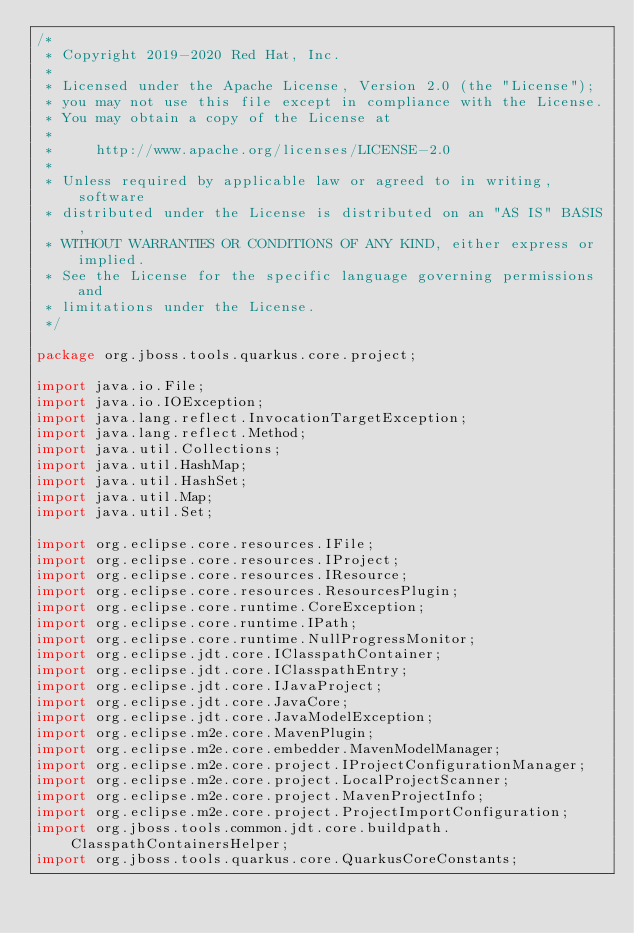<code> <loc_0><loc_0><loc_500><loc_500><_Java_>/*
 * Copyright 2019-2020 Red Hat, Inc.
 *
 * Licensed under the Apache License, Version 2.0 (the "License");
 * you may not use this file except in compliance with the License.
 * You may obtain a copy of the License at
 *
 *     http://www.apache.org/licenses/LICENSE-2.0
 *
 * Unless required by applicable law or agreed to in writing, software
 * distributed under the License is distributed on an "AS IS" BASIS,
 * WITHOUT WARRANTIES OR CONDITIONS OF ANY KIND, either express or implied.
 * See the License for the specific language governing permissions and
 * limitations under the License.
 */

package org.jboss.tools.quarkus.core.project;

import java.io.File;
import java.io.IOException;
import java.lang.reflect.InvocationTargetException;
import java.lang.reflect.Method;
import java.util.Collections;
import java.util.HashMap;
import java.util.HashSet;
import java.util.Map;
import java.util.Set;

import org.eclipse.core.resources.IFile;
import org.eclipse.core.resources.IProject;
import org.eclipse.core.resources.IResource;
import org.eclipse.core.resources.ResourcesPlugin;
import org.eclipse.core.runtime.CoreException;
import org.eclipse.core.runtime.IPath;
import org.eclipse.core.runtime.NullProgressMonitor;
import org.eclipse.jdt.core.IClasspathContainer;
import org.eclipse.jdt.core.IClasspathEntry;
import org.eclipse.jdt.core.IJavaProject;
import org.eclipse.jdt.core.JavaCore;
import org.eclipse.jdt.core.JavaModelException;
import org.eclipse.m2e.core.MavenPlugin;
import org.eclipse.m2e.core.embedder.MavenModelManager;
import org.eclipse.m2e.core.project.IProjectConfigurationManager;
import org.eclipse.m2e.core.project.LocalProjectScanner;
import org.eclipse.m2e.core.project.MavenProjectInfo;
import org.eclipse.m2e.core.project.ProjectImportConfiguration;
import org.jboss.tools.common.jdt.core.buildpath.ClasspathContainersHelper;
import org.jboss.tools.quarkus.core.QuarkusCoreConstants;</code> 